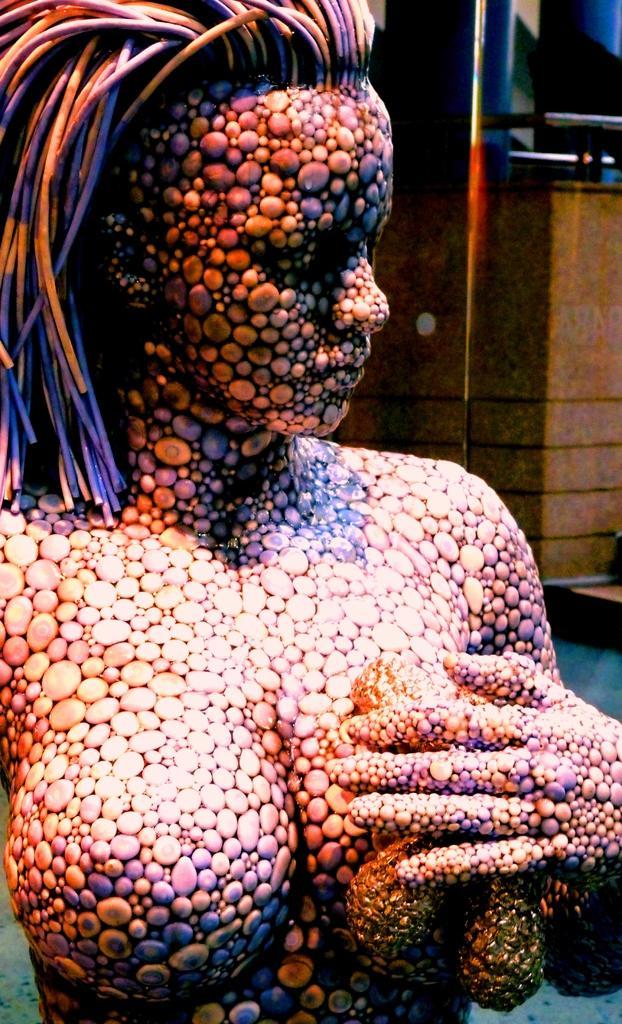Could you give a brief overview of what you see in this image? In this image we can see a statue. In the background of the image, we can see a wall and a glass. 